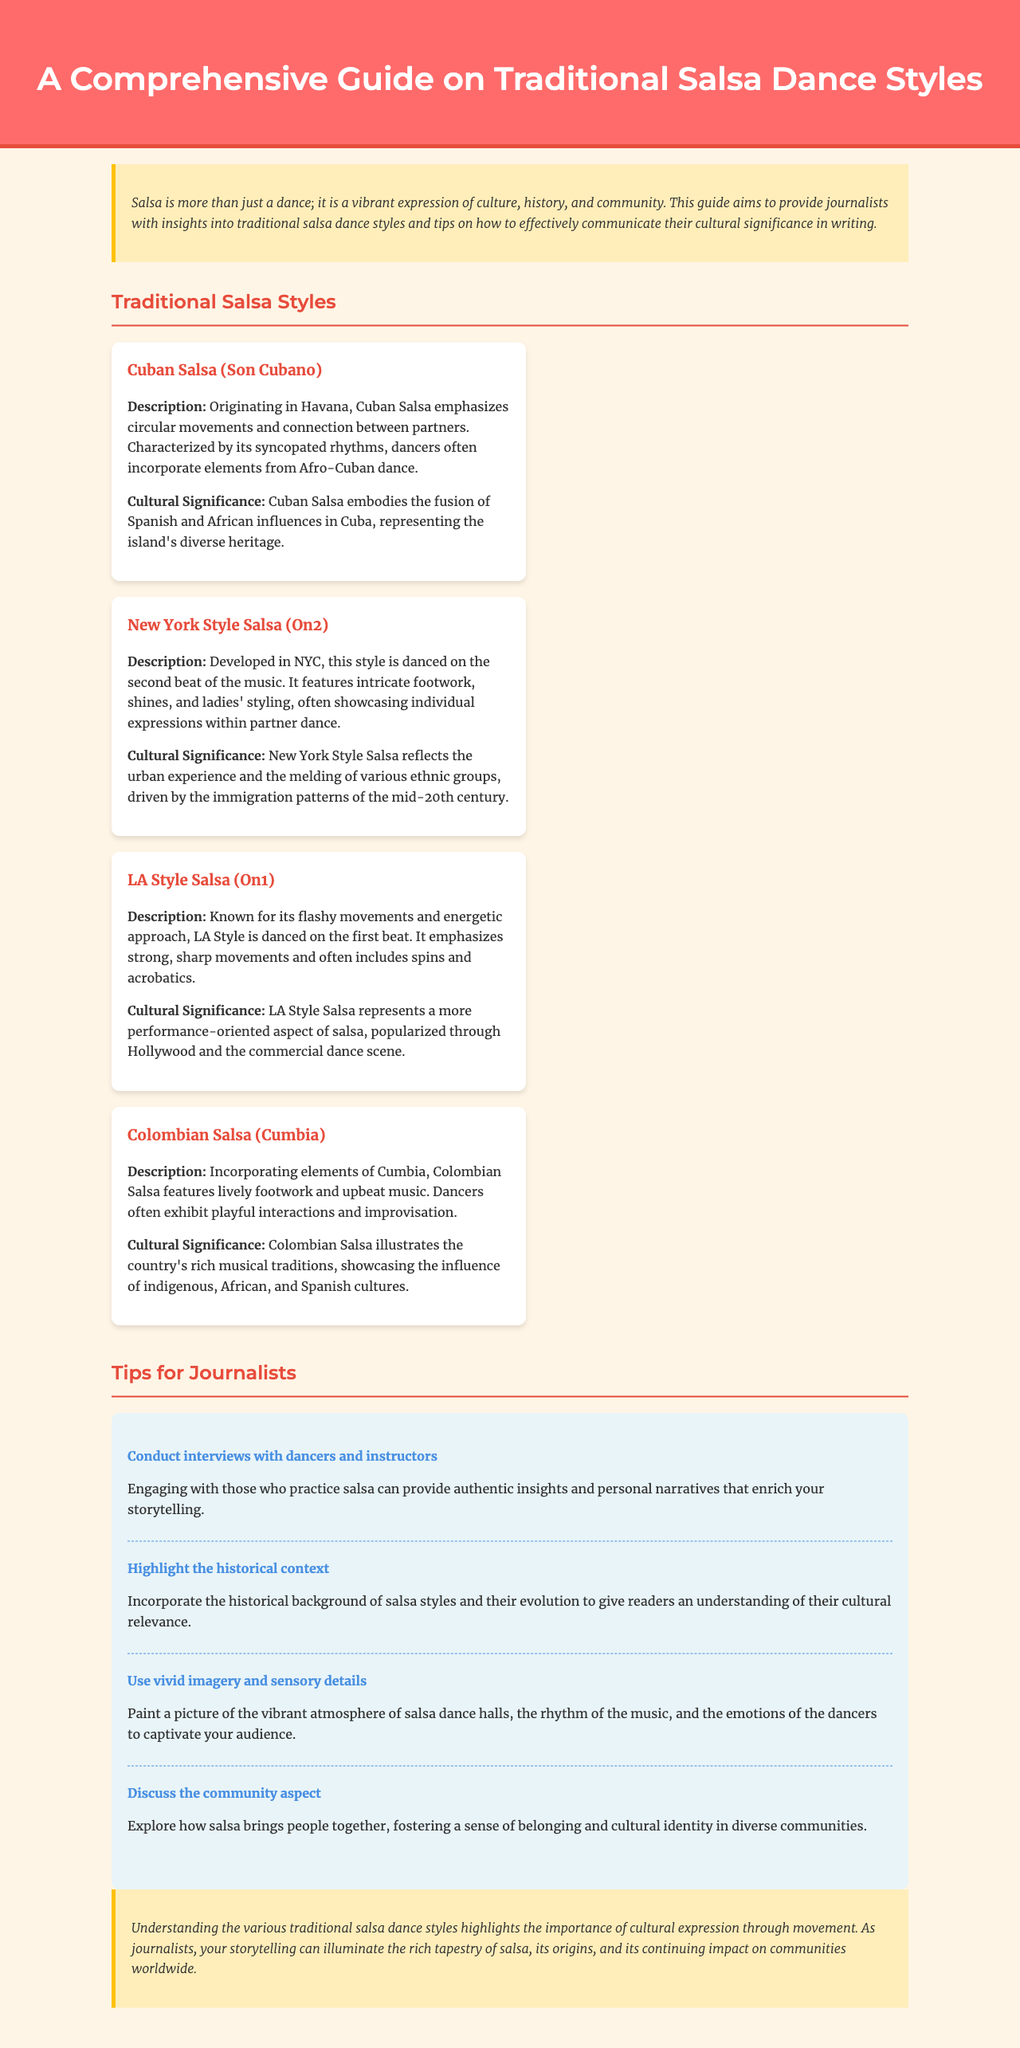What is the title of the document? The title of the document is specified in the header section of the HTML, which is also prominently displayed at the top of the rendered page.
Answer: A Comprehensive Guide on Traditional Salsa Dance Styles How many traditional salsa styles are listed in the document? The document lists four distinct traditional salsa styles under the 'Traditional Salsa Styles' section.
Answer: Four What style is described as emphasizing circular movements? The description mentions that Cuban Salsa is characterized by circular movements and connections between partners.
Answer: Cuban Salsa (Son Cubano) Which salsa style is danced on the second beat of the music? The document explicitly states that New York Style Salsa (On2) is danced on the second beat of the music.
Answer: New York Style Salsa (On2) What community aspect is highlighted in the tips for journalists? One of the tips emphasizes the importance of exploring how salsa fosters a sense of belonging and cultural identity in communities.
Answer: Community aspect What is one tip for journalists to enhance their storytelling about salsa? The document offers several tips; one of them is to use vivid imagery and sensory details to captivate the audience.
Answer: Use vivid imagery and sensory details 